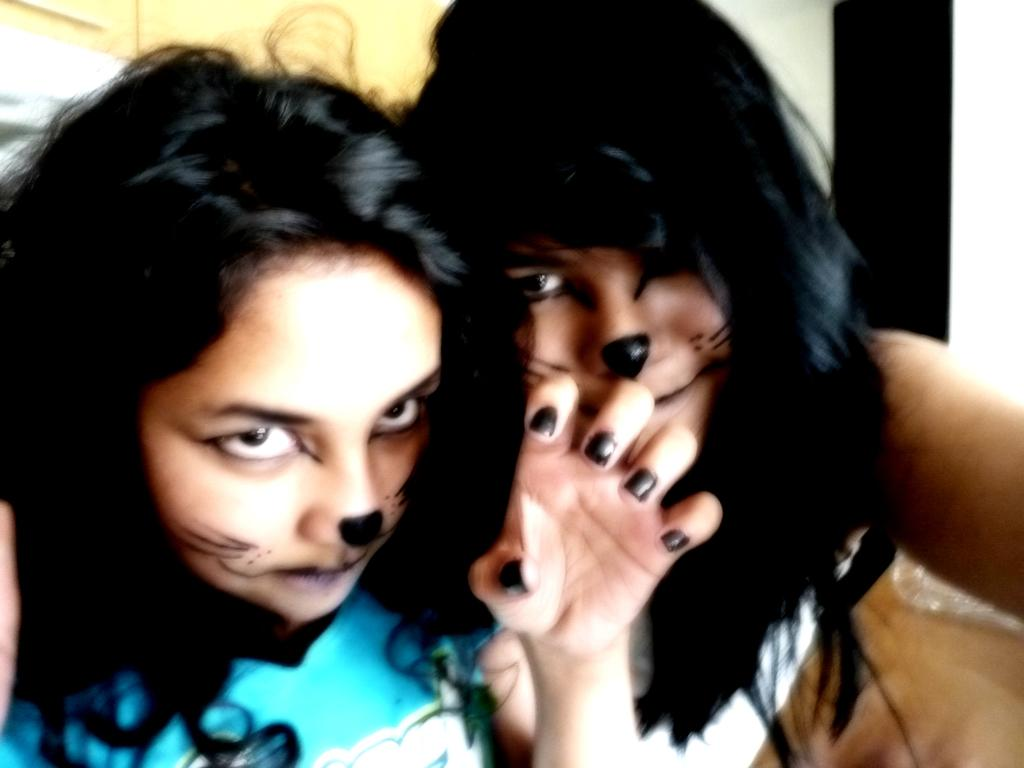How many people are in the image? There are two ladies in the image. What can be observed about the background of the image? The background of the image is blurred. How many fingers can be seen on the nose of the lady on the left? There are no fingers visible on the nose of the lady on the left, as the image does not show any fingers or noses in such a position. 